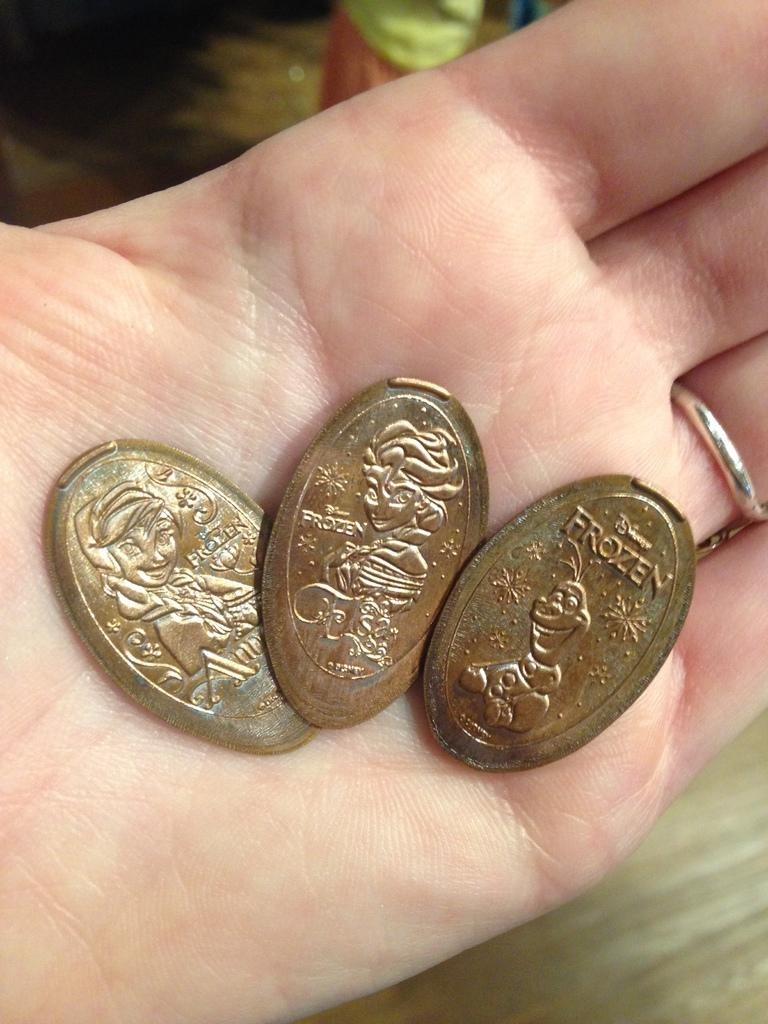<image>
Give a short and clear explanation of the subsequent image. Three Gold coins that a hand is holding, from which are in the movie, Disney's Frozen. 